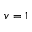<formula> <loc_0><loc_0><loc_500><loc_500>v = 1</formula> 